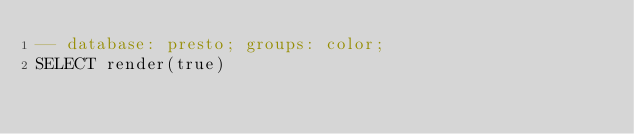<code> <loc_0><loc_0><loc_500><loc_500><_SQL_>-- database: presto; groups: color;
SELECT render(true)
</code> 